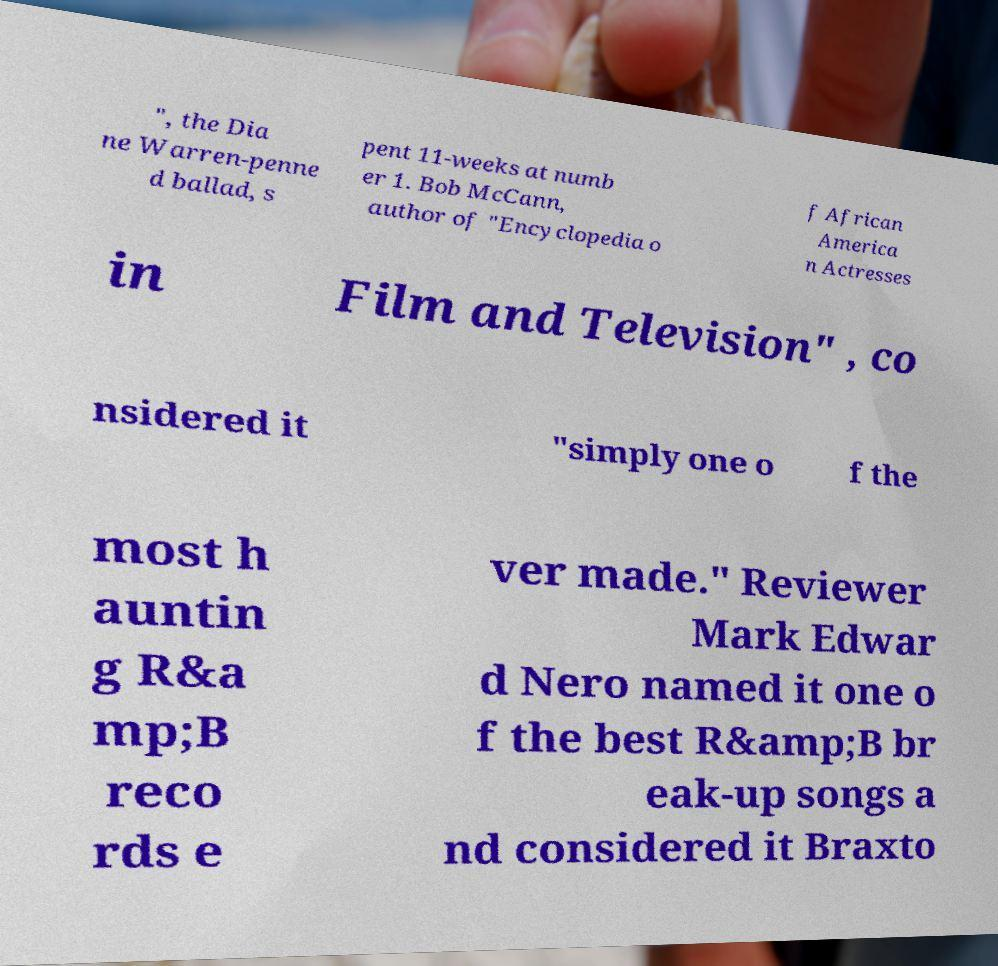For documentation purposes, I need the text within this image transcribed. Could you provide that? ", the Dia ne Warren-penne d ballad, s pent 11-weeks at numb er 1. Bob McCann, author of "Encyclopedia o f African America n Actresses in Film and Television" , co nsidered it "simply one o f the most h auntin g R&a mp;B reco rds e ver made." Reviewer Mark Edwar d Nero named it one o f the best R&amp;B br eak-up songs a nd considered it Braxto 